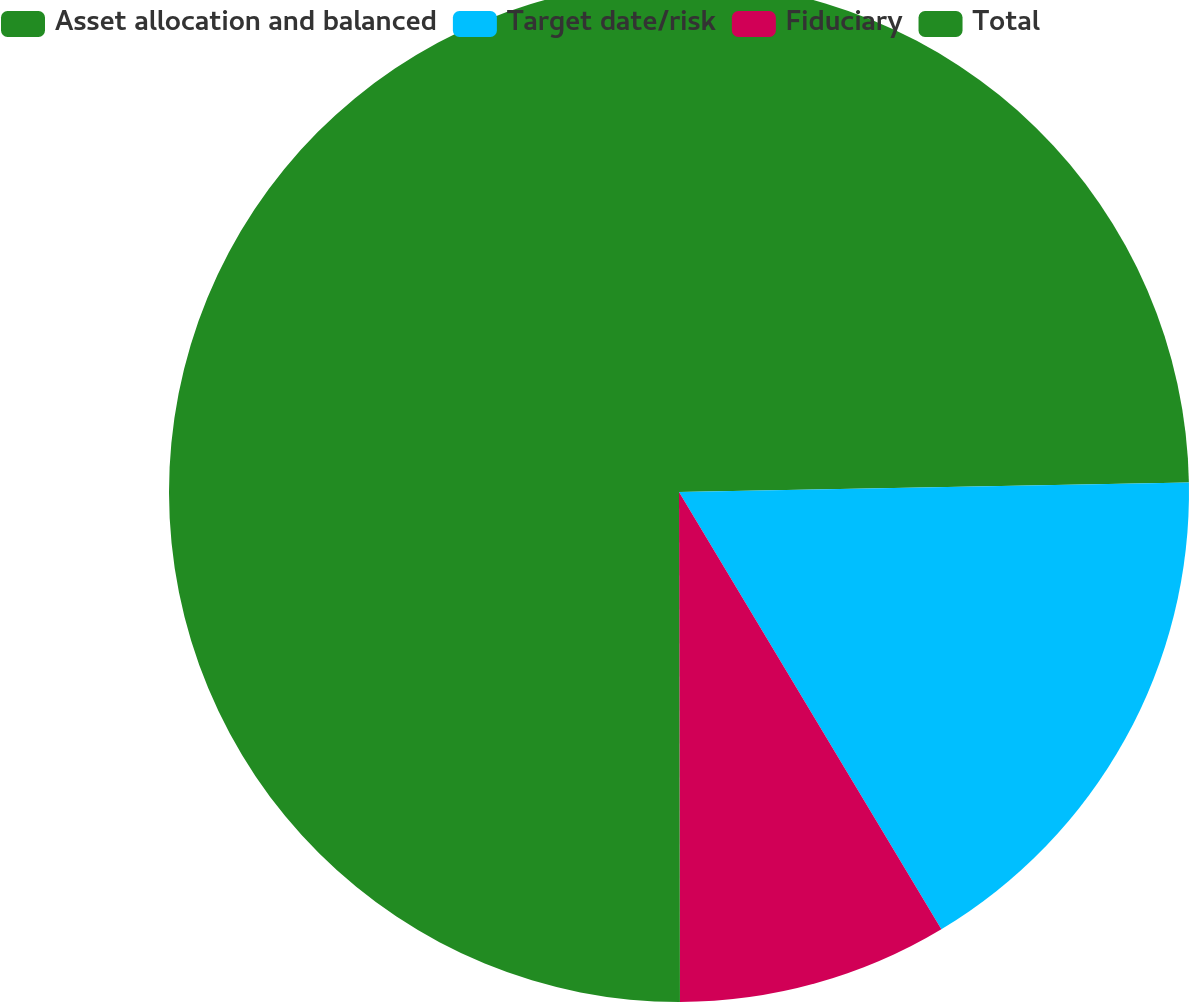Convert chart to OTSL. <chart><loc_0><loc_0><loc_500><loc_500><pie_chart><fcel>Asset allocation and balanced<fcel>Target date/risk<fcel>Fiduciary<fcel>Total<nl><fcel>24.7%<fcel>16.7%<fcel>8.57%<fcel>50.03%<nl></chart> 